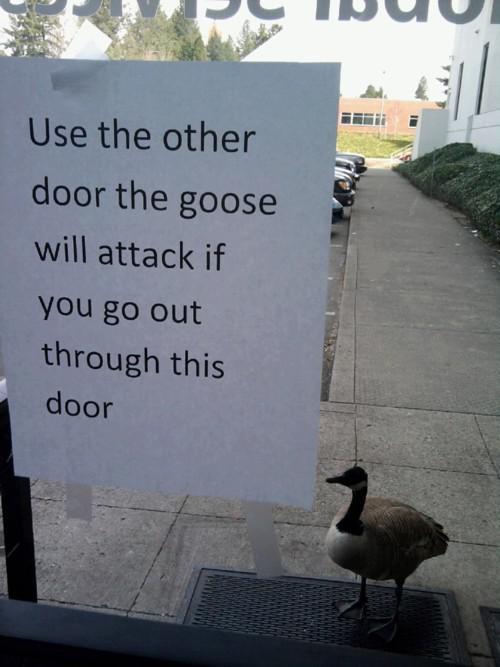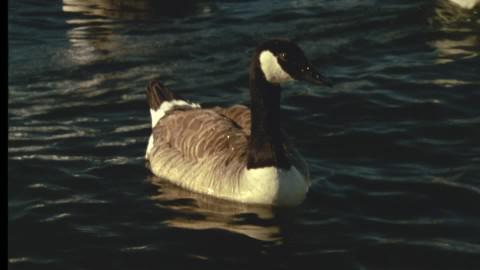The first image is the image on the left, the second image is the image on the right. Examine the images to the left and right. Is the description "There is one eagle" accurate? Answer yes or no. No. The first image is the image on the left, the second image is the image on the right. Analyze the images presented: Is the assertion "In one image, two birds have wings outstretched with at least one of them in mid air." valid? Answer yes or no. No. 